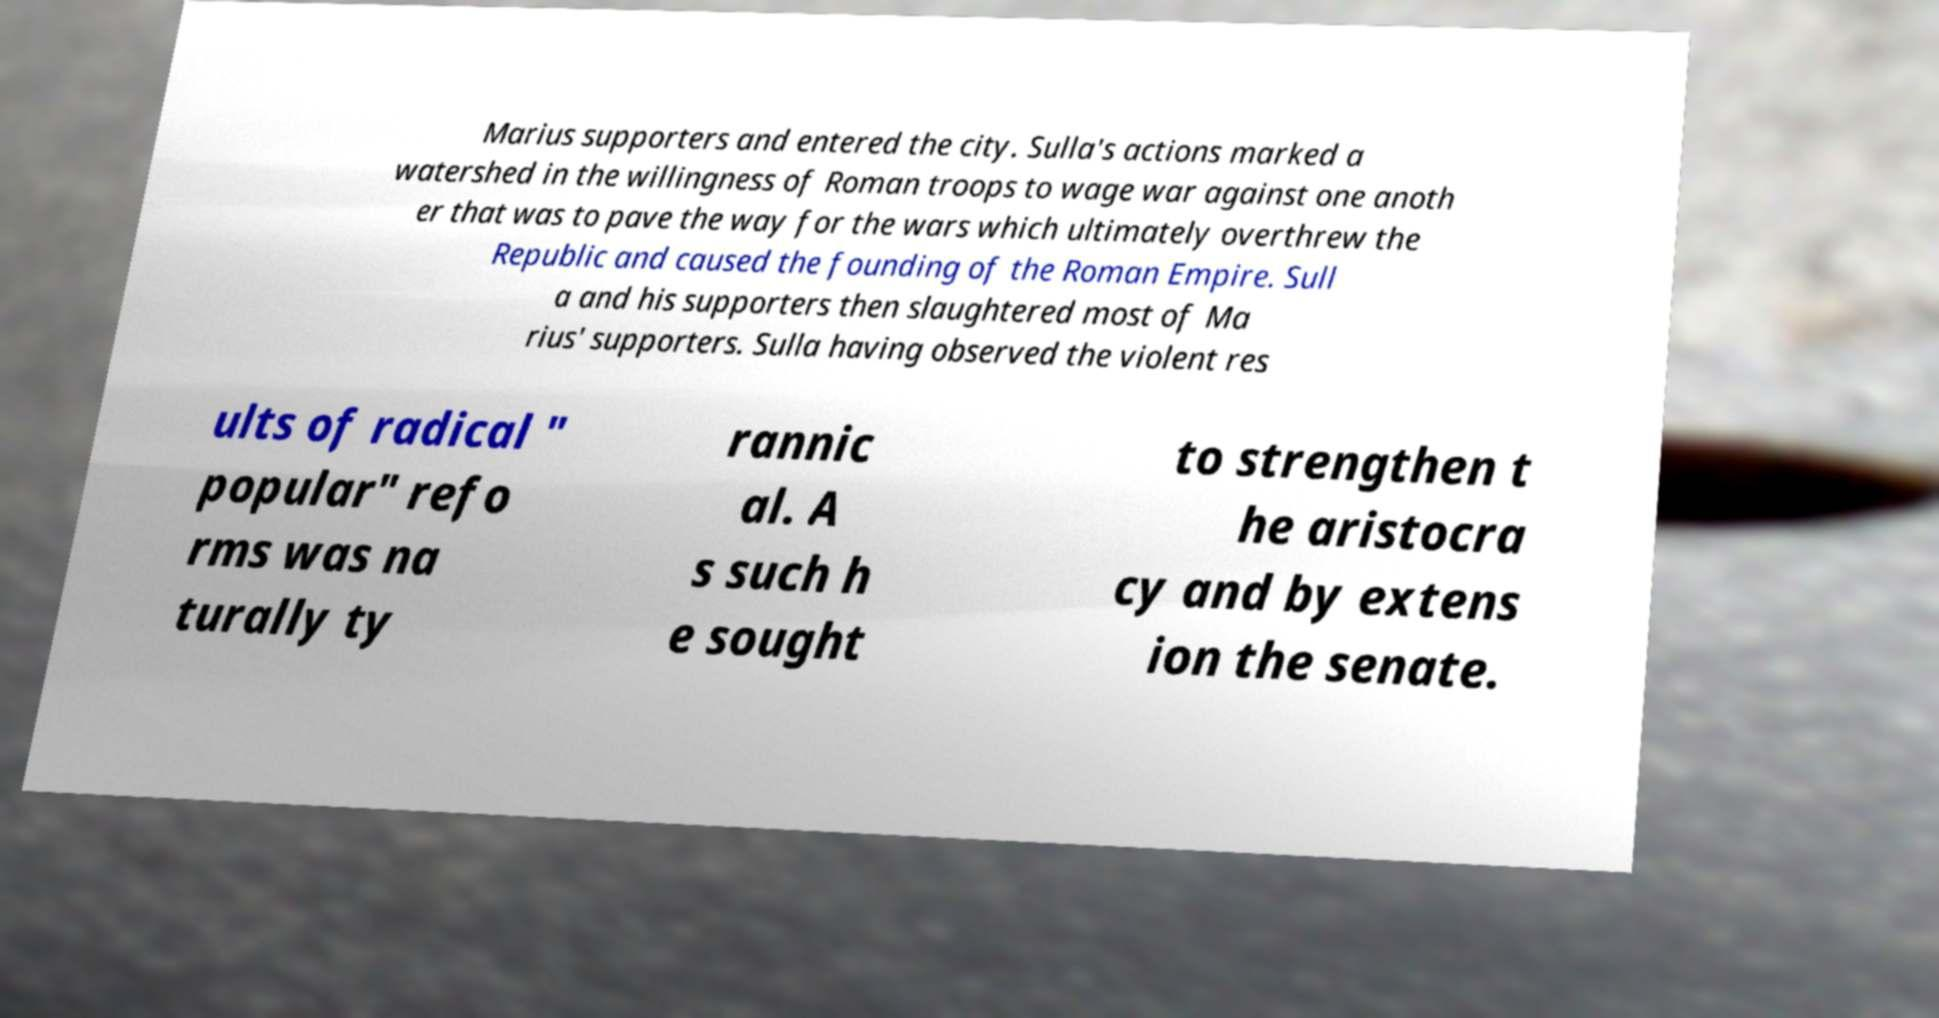Can you accurately transcribe the text from the provided image for me? Marius supporters and entered the city. Sulla's actions marked a watershed in the willingness of Roman troops to wage war against one anoth er that was to pave the way for the wars which ultimately overthrew the Republic and caused the founding of the Roman Empire. Sull a and his supporters then slaughtered most of Ma rius' supporters. Sulla having observed the violent res ults of radical " popular" refo rms was na turally ty rannic al. A s such h e sought to strengthen t he aristocra cy and by extens ion the senate. 